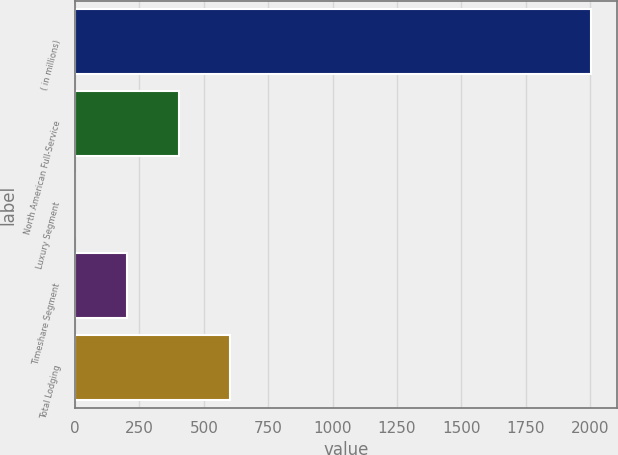Convert chart to OTSL. <chart><loc_0><loc_0><loc_500><loc_500><bar_chart><fcel>( in millions)<fcel>North American Full-Service<fcel>Luxury Segment<fcel>Timeshare Segment<fcel>Total Lodging<nl><fcel>2005<fcel>401.8<fcel>1<fcel>201.4<fcel>602.2<nl></chart> 